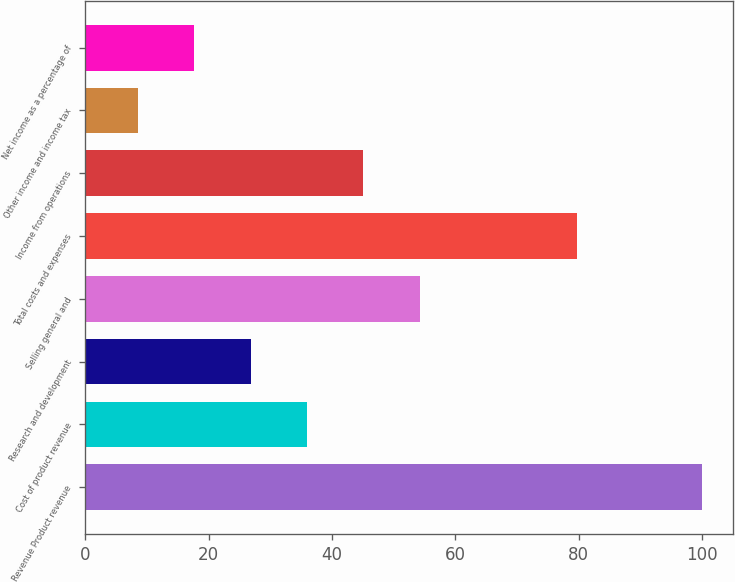Convert chart. <chart><loc_0><loc_0><loc_500><loc_500><bar_chart><fcel>Revenue Product revenue<fcel>Cost of product revenue<fcel>Research and development<fcel>Selling general and<fcel>Total costs and expenses<fcel>Income from operations<fcel>Other income and income tax<fcel>Net income as a percentage of<nl><fcel>100<fcel>35.95<fcel>26.8<fcel>54.25<fcel>79.8<fcel>45.1<fcel>8.5<fcel>17.65<nl></chart> 